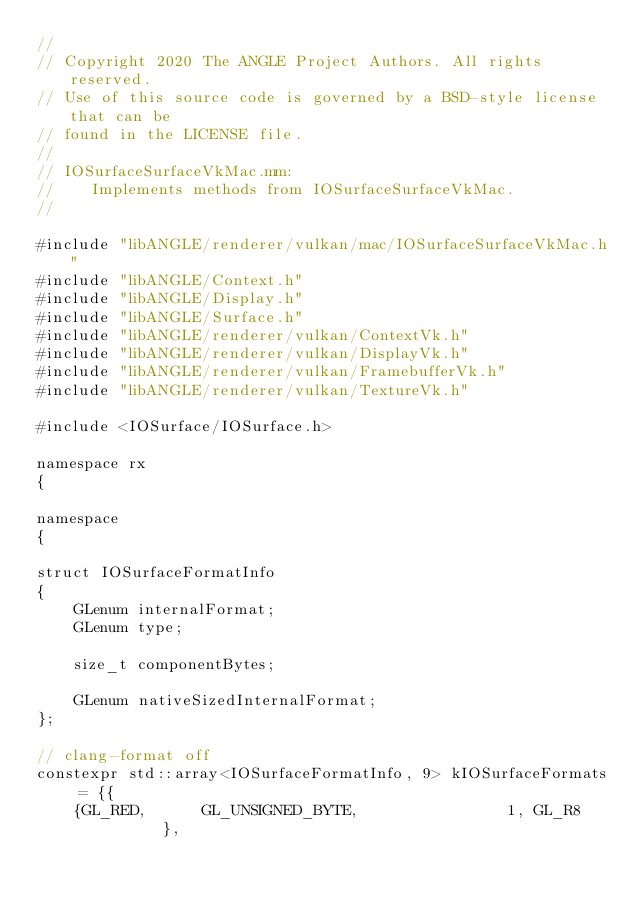<code> <loc_0><loc_0><loc_500><loc_500><_ObjectiveC_>//
// Copyright 2020 The ANGLE Project Authors. All rights reserved.
// Use of this source code is governed by a BSD-style license that can be
// found in the LICENSE file.
//
// IOSurfaceSurfaceVkMac.mm:
//    Implements methods from IOSurfaceSurfaceVkMac.
//

#include "libANGLE/renderer/vulkan/mac/IOSurfaceSurfaceVkMac.h"
#include "libANGLE/Context.h"
#include "libANGLE/Display.h"
#include "libANGLE/Surface.h"
#include "libANGLE/renderer/vulkan/ContextVk.h"
#include "libANGLE/renderer/vulkan/DisplayVk.h"
#include "libANGLE/renderer/vulkan/FramebufferVk.h"
#include "libANGLE/renderer/vulkan/TextureVk.h"

#include <IOSurface/IOSurface.h>

namespace rx
{

namespace
{

struct IOSurfaceFormatInfo
{
    GLenum internalFormat;
    GLenum type;

    size_t componentBytes;

    GLenum nativeSizedInternalFormat;
};

// clang-format off
constexpr std::array<IOSurfaceFormatInfo, 9> kIOSurfaceFormats = {{
    {GL_RED,      GL_UNSIGNED_BYTE,                1, GL_R8       },</code> 